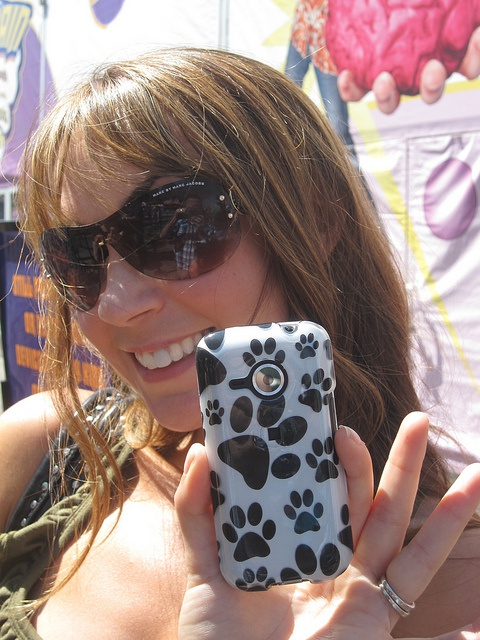Describe the objects in this image and their specific colors. I can see people in lavender, brown, black, gray, and maroon tones and cell phone in lavender, black, darkgray, and gray tones in this image. 